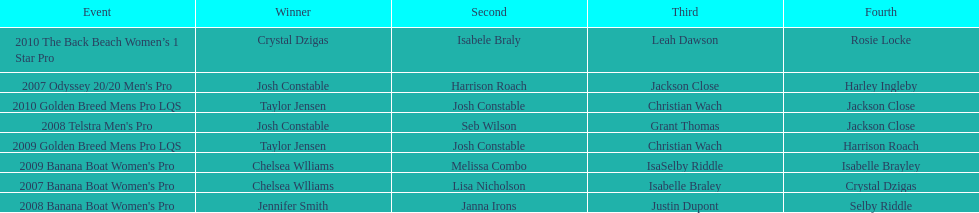How many times was josh constable second? 2. 